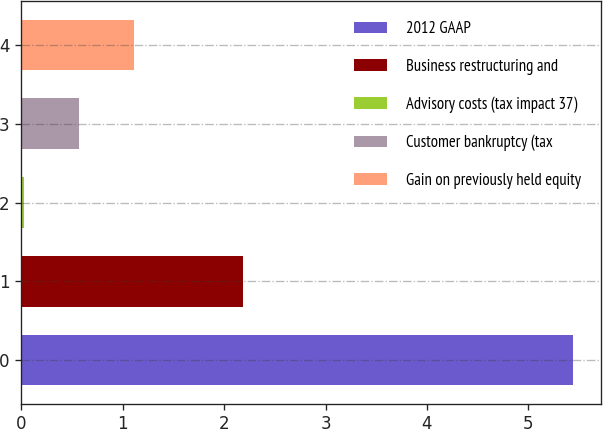<chart> <loc_0><loc_0><loc_500><loc_500><bar_chart><fcel>2012 GAAP<fcel>Business restructuring and<fcel>Advisory costs (tax impact 37)<fcel>Customer bankruptcy (tax<fcel>Gain on previously held equity<nl><fcel>5.44<fcel>2.19<fcel>0.03<fcel>0.57<fcel>1.11<nl></chart> 